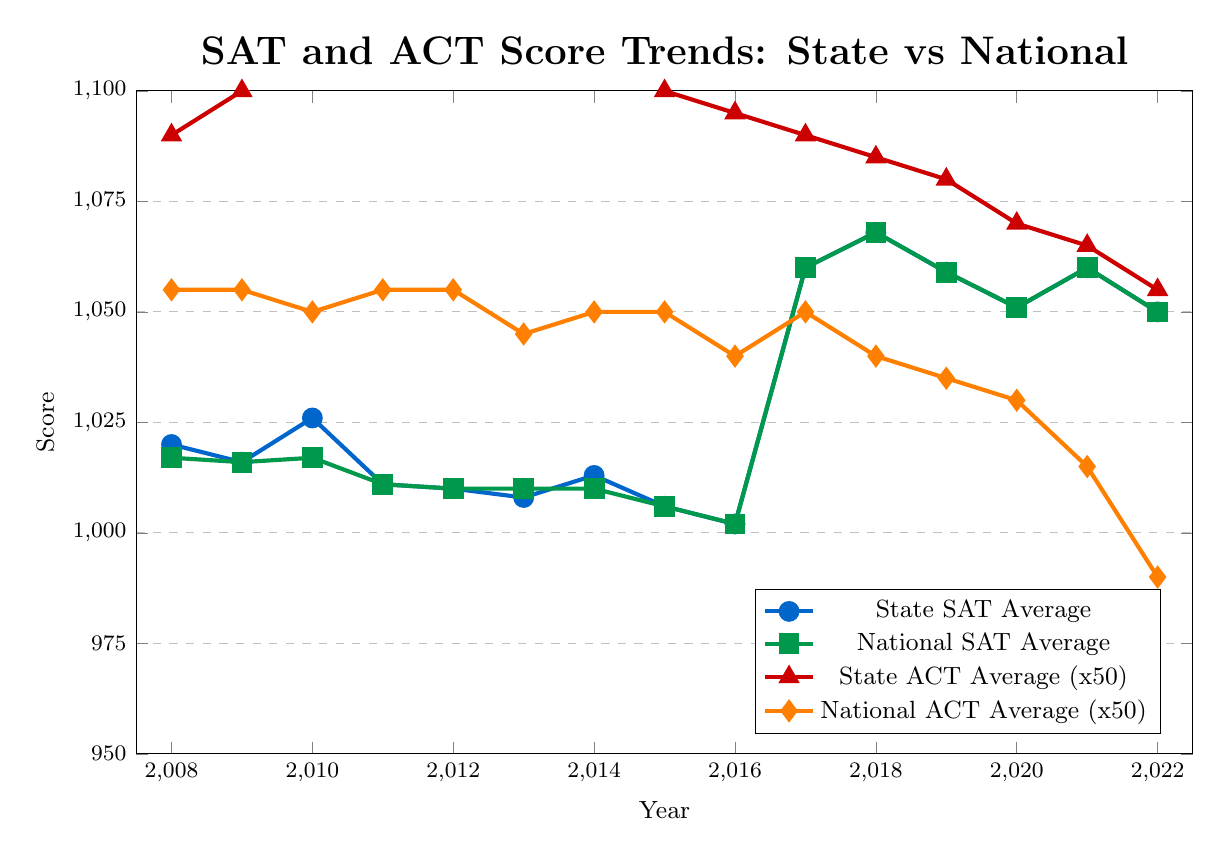What's the highest SAT average over the 15-year period for the state? By observing the trend line marked in blue, the highest point on the chart corresponds to the year 2018, where it records the highest value.
Answer: 1068 How did the state ACT average change from 2008 to 2022? Look at the trend line marked in red with triangles for the state ACT averages. Note the value at 2008 and the value at 2022, and compare them.
Answer: Decreased from 1090 to 1055 In which year(s) did the State SAT average equal the National SAT average? Identify the points where both the state and national SAT average lines (blue and green) intersect.
Answer: 2009, 2011, 2012, 2015, 2016, 2017, 2021, 2022 What's the visual pattern observed in the State ACT trends relative to the National ACT trends? Observe the red line for state ACT averages and the orange line for national ACT averages. Both show decreasing trends, but the state line consistently remains higher.
Answer: Decreasing but consistently higher From 2014 to 2015, which had the largest decline, the state SAT or the national SAT? Compare the difference between the state SAT values in 2014 and 2015 and the national SAT values in the same period.
Answer: State SAT declined more Which year had the smallest gap between the state ACT average and the national ACT average? Calculate the difference between the state and national ACT averages for each year and identify the smallest gap.
Answer: 2022 In which year did both SAT averages (state and national) see a simultaneous increase? Check the trend lines for both SAT averages and identify years where both lines go up together.
Answer: 2017 